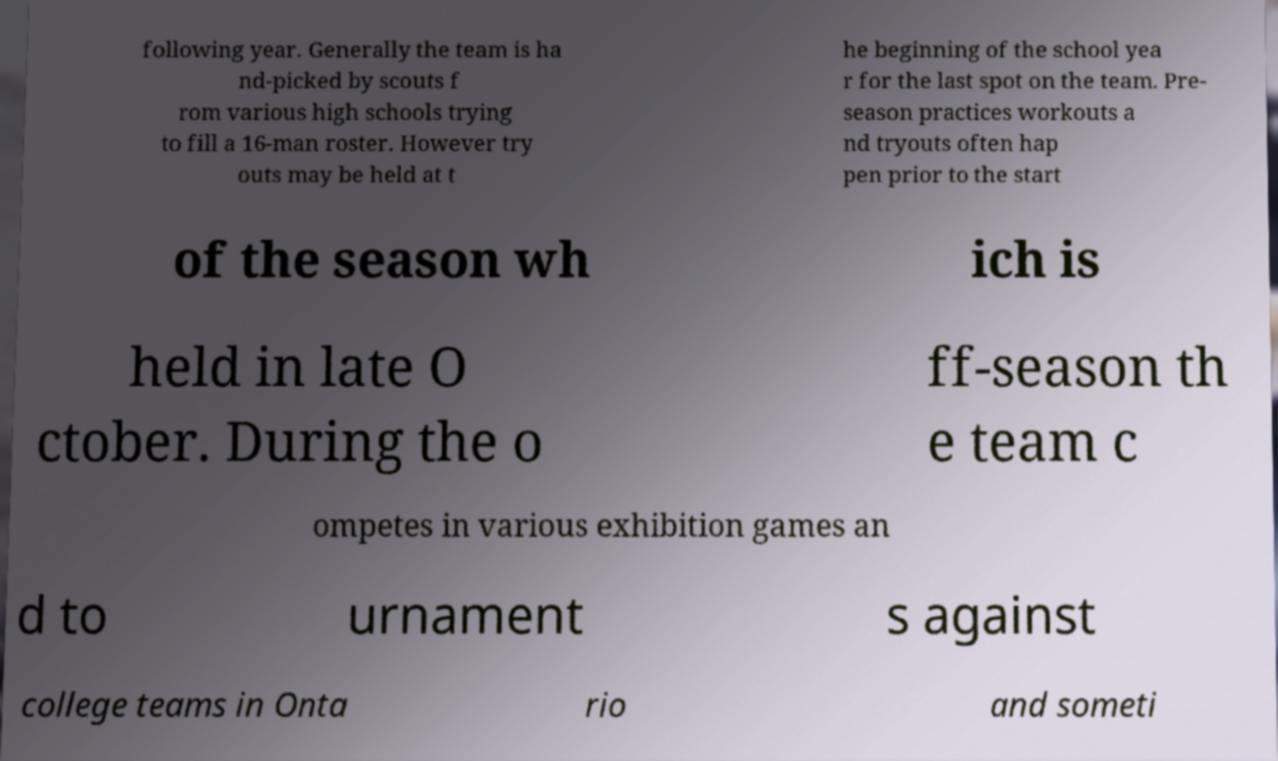Could you assist in decoding the text presented in this image and type it out clearly? following year. Generally the team is ha nd-picked by scouts f rom various high schools trying to fill a 16-man roster. However try outs may be held at t he beginning of the school yea r for the last spot on the team. Pre- season practices workouts a nd tryouts often hap pen prior to the start of the season wh ich is held in late O ctober. During the o ff-season th e team c ompetes in various exhibition games an d to urnament s against college teams in Onta rio and someti 